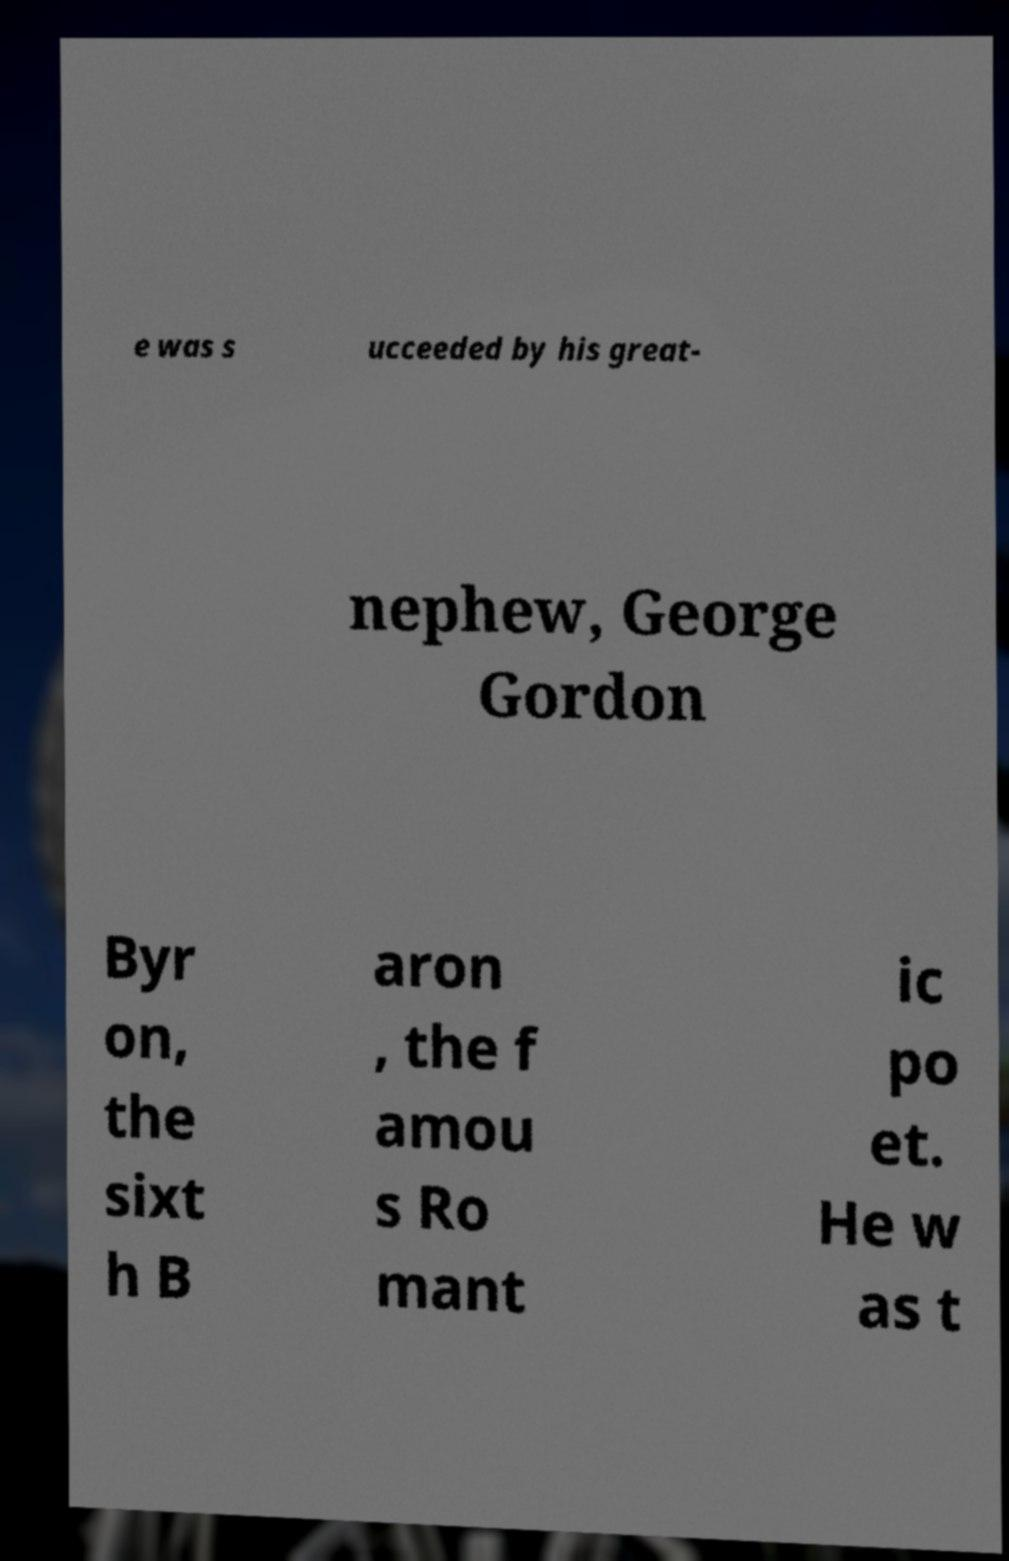I need the written content from this picture converted into text. Can you do that? e was s ucceeded by his great- nephew, George Gordon Byr on, the sixt h B aron , the f amou s Ro mant ic po et. He w as t 